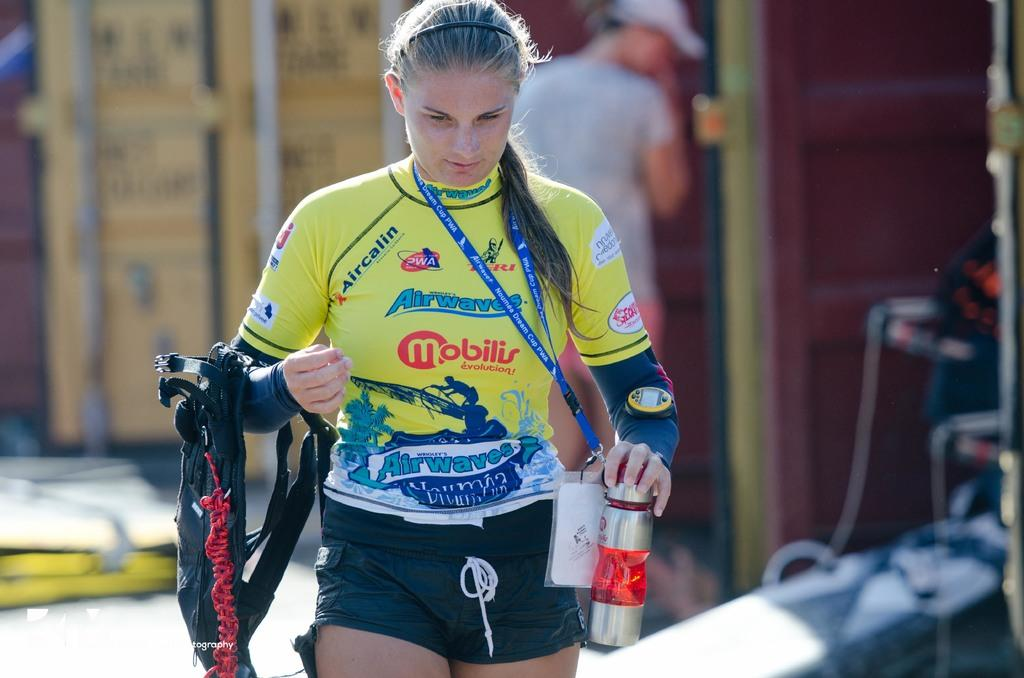<image>
Provide a brief description of the given image. Woman wearing a colorful shirt featuring many different advertisements such as Airwaves. 